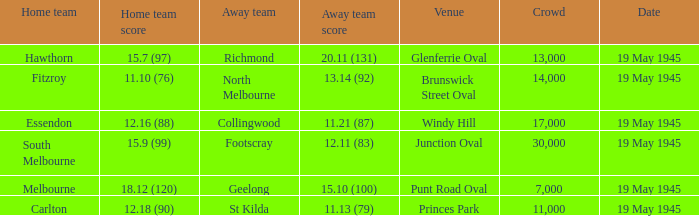Could you help me parse every detail presented in this table? {'header': ['Home team', 'Home team score', 'Away team', 'Away team score', 'Venue', 'Crowd', 'Date'], 'rows': [['Hawthorn', '15.7 (97)', 'Richmond', '20.11 (131)', 'Glenferrie Oval', '13,000', '19 May 1945'], ['Fitzroy', '11.10 (76)', 'North Melbourne', '13.14 (92)', 'Brunswick Street Oval', '14,000', '19 May 1945'], ['Essendon', '12.16 (88)', 'Collingwood', '11.21 (87)', 'Windy Hill', '17,000', '19 May 1945'], ['South Melbourne', '15.9 (99)', 'Footscray', '12.11 (83)', 'Junction Oval', '30,000', '19 May 1945'], ['Melbourne', '18.12 (120)', 'Geelong', '15.10 (100)', 'Punt Road Oval', '7,000', '19 May 1945'], ['Carlton', '12.18 (90)', 'St Kilda', '11.13 (79)', 'Princes Park', '11,000', '19 May 1945']]} On which date was Essendon the home team? 19 May 1945. 